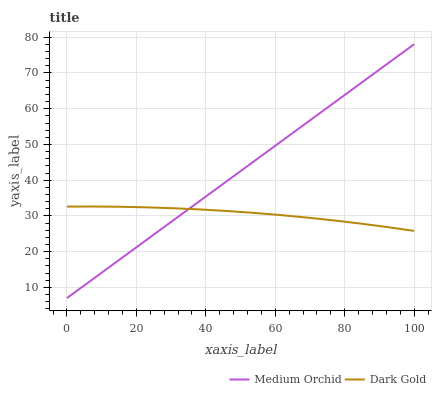Does Dark Gold have the minimum area under the curve?
Answer yes or no. Yes. Does Medium Orchid have the maximum area under the curve?
Answer yes or no. Yes. Does Dark Gold have the maximum area under the curve?
Answer yes or no. No. Is Medium Orchid the smoothest?
Answer yes or no. Yes. Is Dark Gold the roughest?
Answer yes or no. Yes. Is Dark Gold the smoothest?
Answer yes or no. No. Does Medium Orchid have the lowest value?
Answer yes or no. Yes. Does Dark Gold have the lowest value?
Answer yes or no. No. Does Medium Orchid have the highest value?
Answer yes or no. Yes. Does Dark Gold have the highest value?
Answer yes or no. No. Does Dark Gold intersect Medium Orchid?
Answer yes or no. Yes. Is Dark Gold less than Medium Orchid?
Answer yes or no. No. Is Dark Gold greater than Medium Orchid?
Answer yes or no. No. 